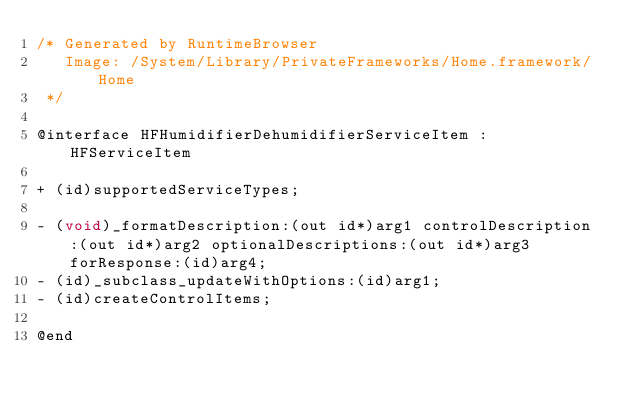Convert code to text. <code><loc_0><loc_0><loc_500><loc_500><_C_>/* Generated by RuntimeBrowser
   Image: /System/Library/PrivateFrameworks/Home.framework/Home
 */

@interface HFHumidifierDehumidifierServiceItem : HFServiceItem

+ (id)supportedServiceTypes;

- (void)_formatDescription:(out id*)arg1 controlDescription:(out id*)arg2 optionalDescriptions:(out id*)arg3 forResponse:(id)arg4;
- (id)_subclass_updateWithOptions:(id)arg1;
- (id)createControlItems;

@end
</code> 